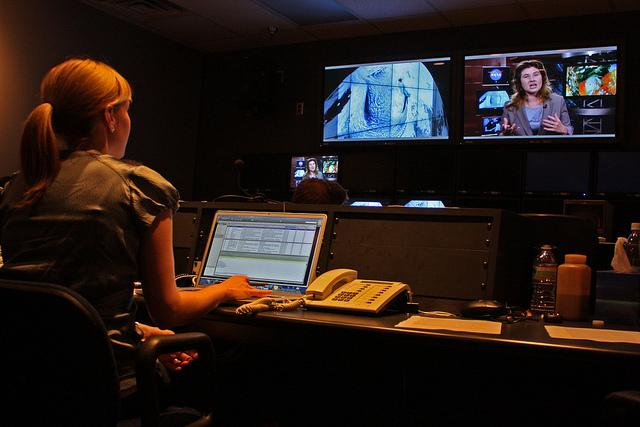What is the woman doing? working 